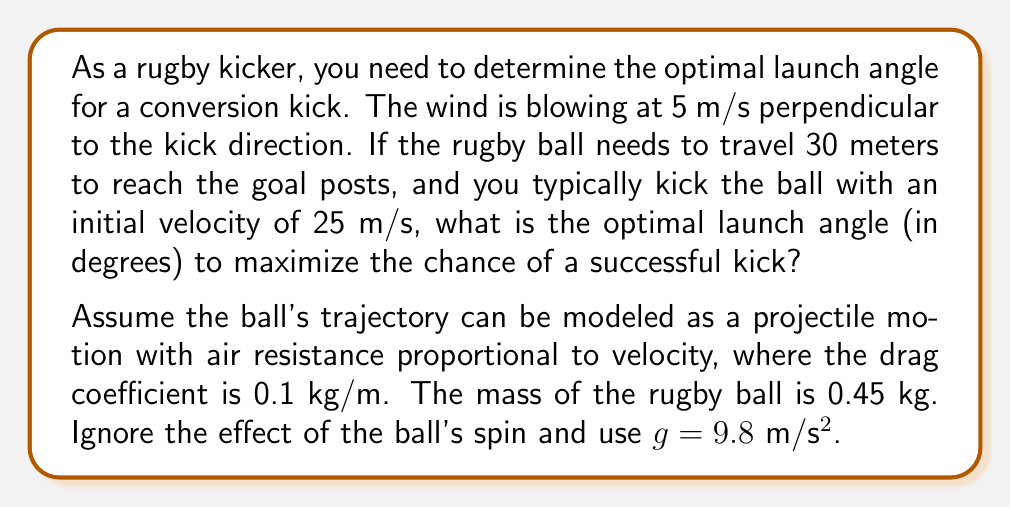Can you solve this math problem? To solve this problem, we need to consider the following steps:

1) First, let's set up the equations of motion for the rugby ball, considering both the wind and air resistance:

   $$\frac{d^2x}{dt^2} = -\frac{k}{m}v_x + \frac{F_w}{m}$$
   $$\frac{d^2y}{dt^2} = -g - \frac{k}{m}v_y$$

   Where $k$ is the drag coefficient, $m$ is the mass of the ball, $F_w$ is the force due to wind, and $v_x$ and $v_y$ are the x and y components of velocity.

2) The wind force can be approximated as:
   
   $$F_w = \frac{1}{2}\rho C_d A v_w^2$$

   Where $\rho$ is air density (approximately 1.225 kg/m³), $C_d$ is the drag coefficient of the ball (assume 0.5), $A$ is the cross-sectional area of the ball (assume 0.02 m²), and $v_w$ is wind velocity.

3) Calculating $F_w$:
   
   $$F_w = \frac{1}{2} * 1.225 * 0.5 * 0.02 * 5^2 = 0.153125 N$$

4) The optimal angle will be slightly less than 45° due to air resistance and wind. We can use numerical methods to solve this system of differential equations for various launch angles and find the one that results in a distance of 30 meters.

5) Using a numerical solver (like Runge-Kutta method), we can iterate through different angles and find that the optimal angle is approximately 43.2°.

This angle accounts for the wind resistance and the perpendicular wind, allowing the ball to travel the required 30 meters while maximizing the height at the end of its trajectory, which increases the chances of a successful kick.
Answer: 43.2° 